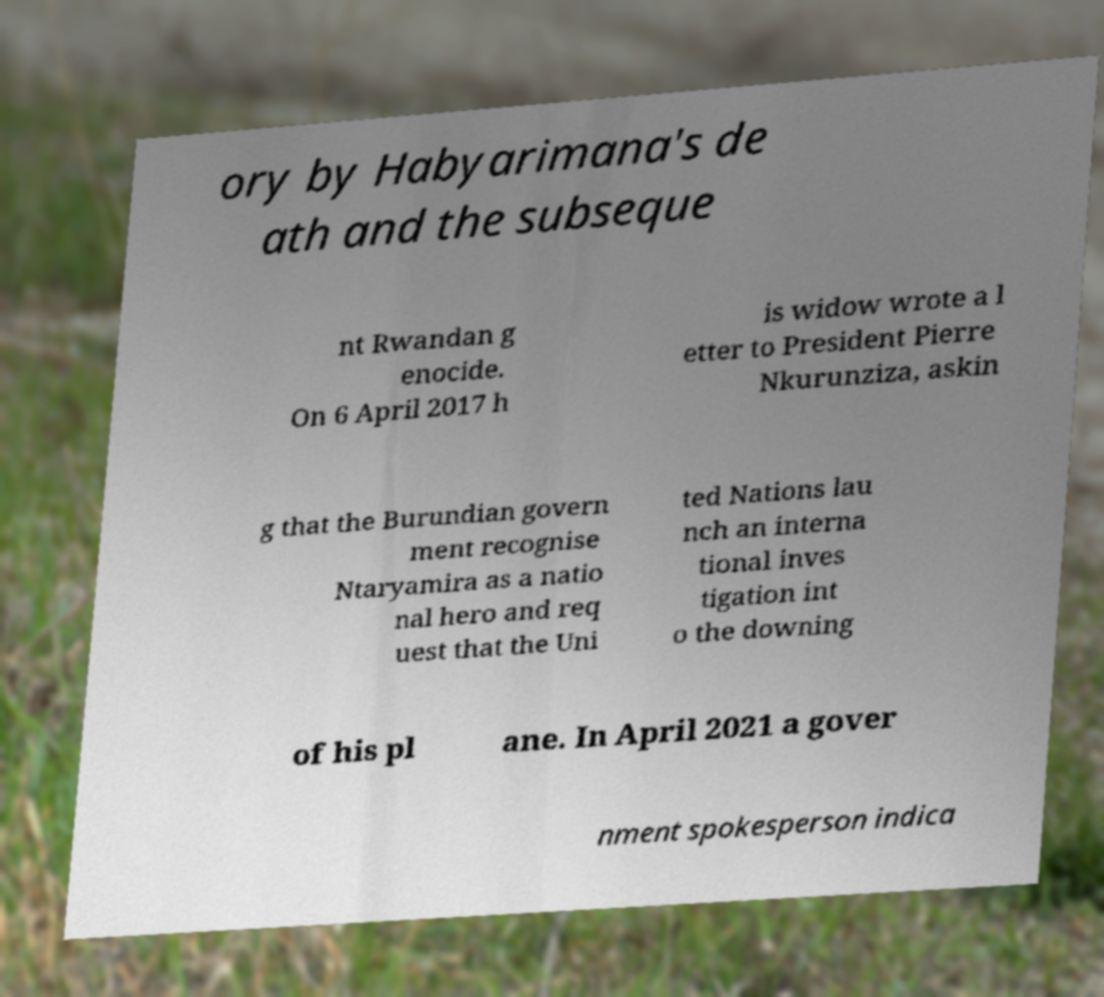Could you extract and type out the text from this image? ory by Habyarimana's de ath and the subseque nt Rwandan g enocide. On 6 April 2017 h is widow wrote a l etter to President Pierre Nkurunziza, askin g that the Burundian govern ment recognise Ntaryamira as a natio nal hero and req uest that the Uni ted Nations lau nch an interna tional inves tigation int o the downing of his pl ane. In April 2021 a gover nment spokesperson indica 